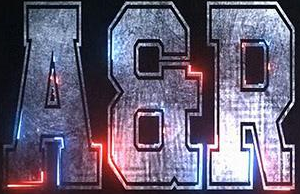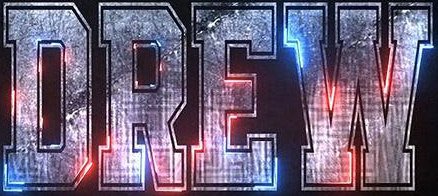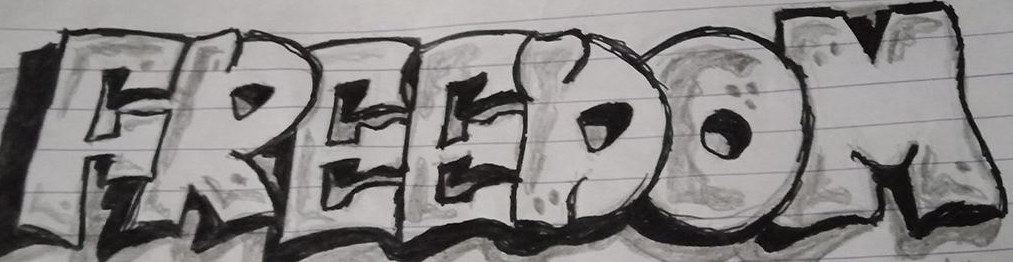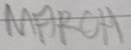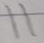Read the text from these images in sequence, separated by a semicolon. AER; DREW; FREEDOM; MARCH; 11 